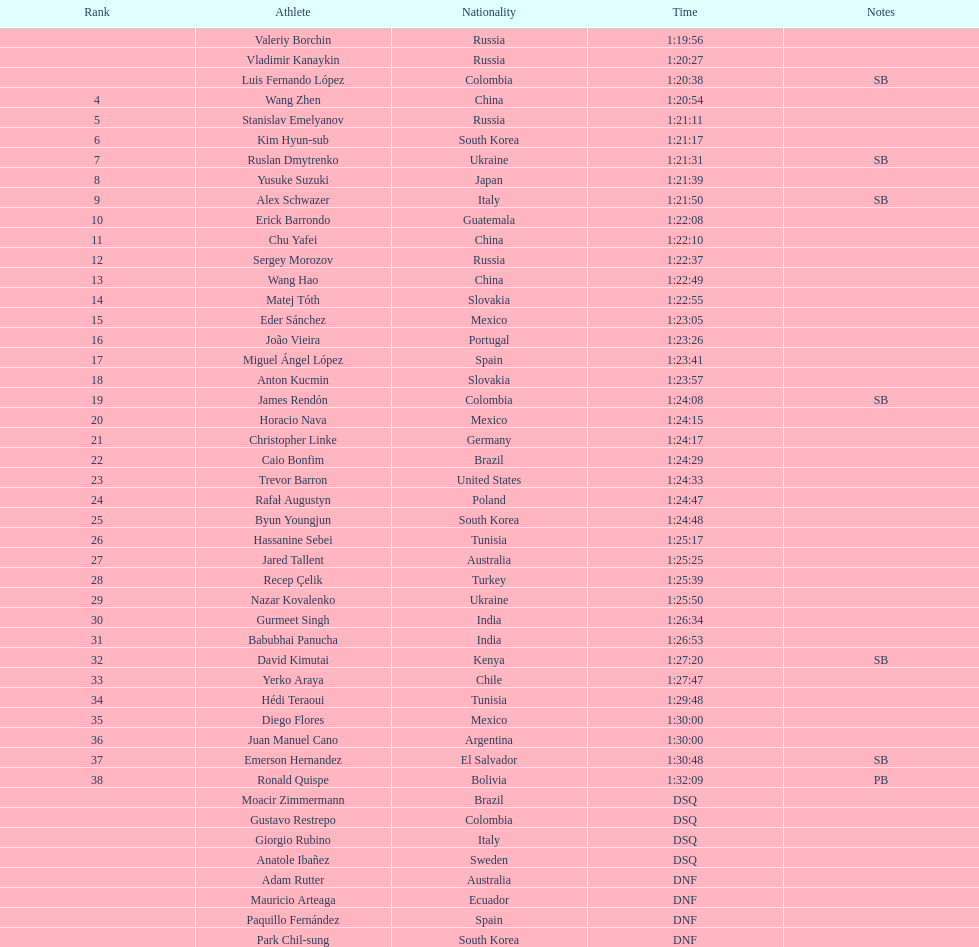Including dsq and dnf athletes, what is the complete number of athletes featured in the rankings chart? 46. 